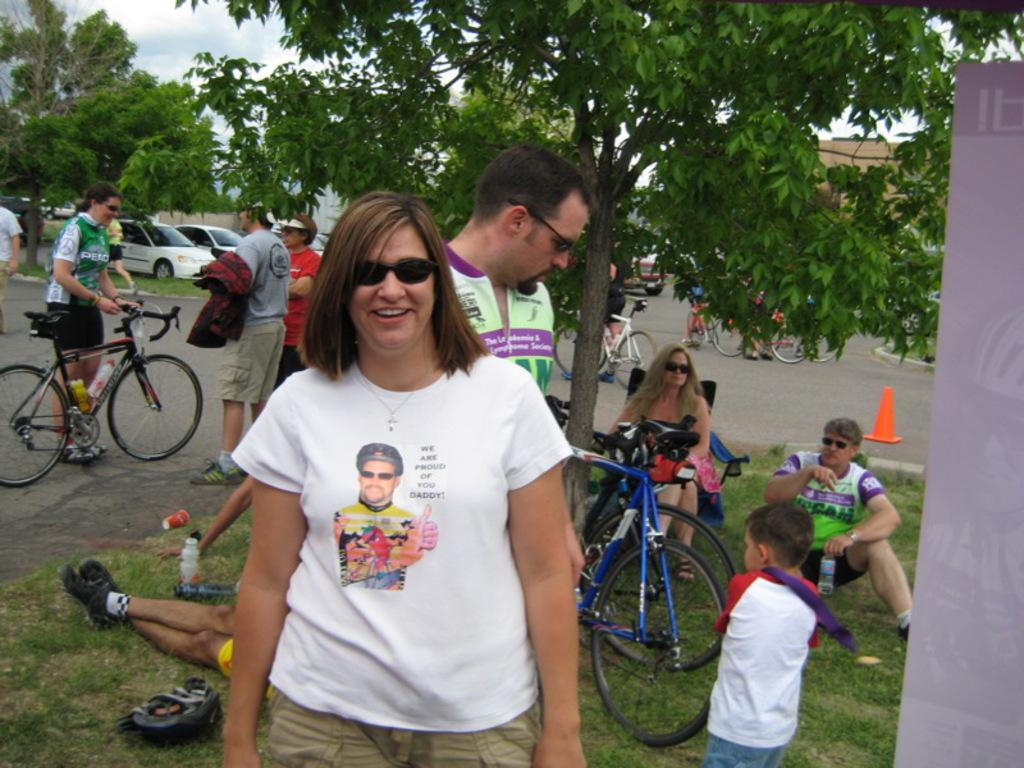What type of vegetation can be seen in the image? There are trees in the image. What part of the natural environment is visible in the image? The sky is visible in the image. What type of vehicles are present in the image? There are cars in the image. What are the people in the image doing? There are people standing on the road in the image. What mode of transportation can be seen in the image besides cars? There is a bicycle in the image. What type of ground surface is present in the image? Grass is present in the image. What is the condition of the sail in the image? There is no sail present in the image. What type of grass is growing on the road in the image? There is no grass growing on the road in the image; it is present on the ground surface. 